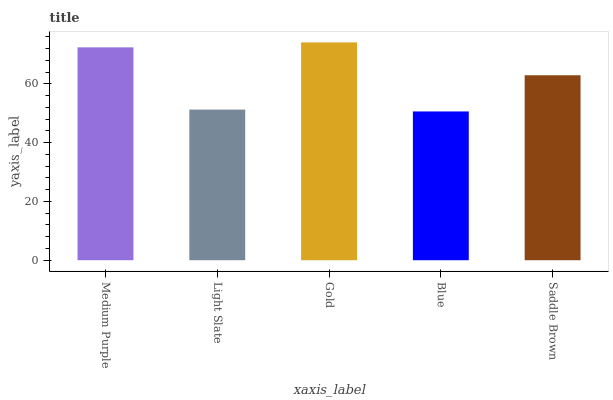Is Blue the minimum?
Answer yes or no. Yes. Is Gold the maximum?
Answer yes or no. Yes. Is Light Slate the minimum?
Answer yes or no. No. Is Light Slate the maximum?
Answer yes or no. No. Is Medium Purple greater than Light Slate?
Answer yes or no. Yes. Is Light Slate less than Medium Purple?
Answer yes or no. Yes. Is Light Slate greater than Medium Purple?
Answer yes or no. No. Is Medium Purple less than Light Slate?
Answer yes or no. No. Is Saddle Brown the high median?
Answer yes or no. Yes. Is Saddle Brown the low median?
Answer yes or no. Yes. Is Light Slate the high median?
Answer yes or no. No. Is Light Slate the low median?
Answer yes or no. No. 